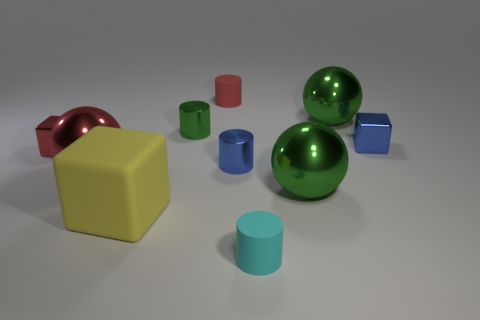Subtract 1 cylinders. How many cylinders are left? 3 Subtract all cylinders. How many objects are left? 6 Subtract all shiny blocks. Subtract all tiny metallic objects. How many objects are left? 4 Add 2 large red balls. How many large red balls are left? 3 Add 3 big green shiny objects. How many big green shiny objects exist? 5 Subtract 0 gray cylinders. How many objects are left? 10 